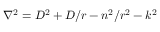Convert formula to latex. <formula><loc_0><loc_0><loc_500><loc_500>\nabla ^ { 2 } = D ^ { 2 } + D / r - n ^ { 2 } / r ^ { 2 } - k ^ { 2 }</formula> 